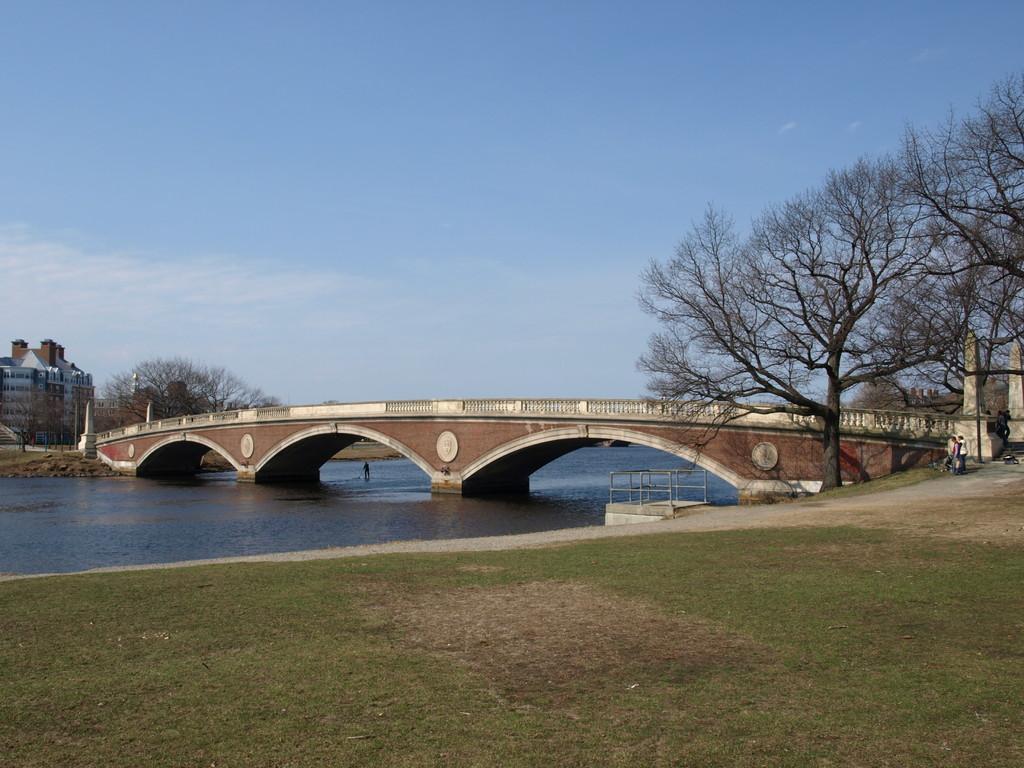Can you describe this image briefly? In the center of the image there is a bridge. There is water. At the bottom of the image there is grass. At the top of the image there is sky. There are trees. To the left side of the image there is a building. 